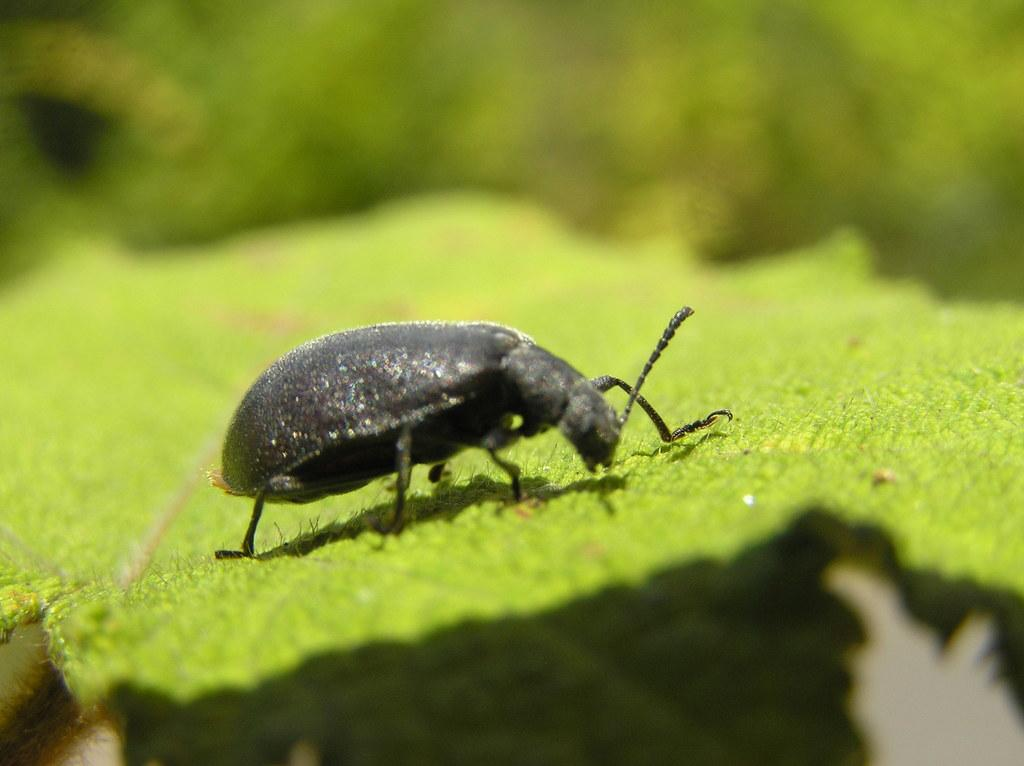Where was the image taken? The image was taken outdoors. Can you describe the background of the image? The background of the image is slightly blurred. What is the main subject of the image? There is a bug in the middle of the image. What is the bug sitting on? The bug is on a leaf. What type of humor can be seen in the image? There is no humor present in the image; it features a bug on a leaf. How many tomatoes are visible in the image? There are no tomatoes present in the image. 